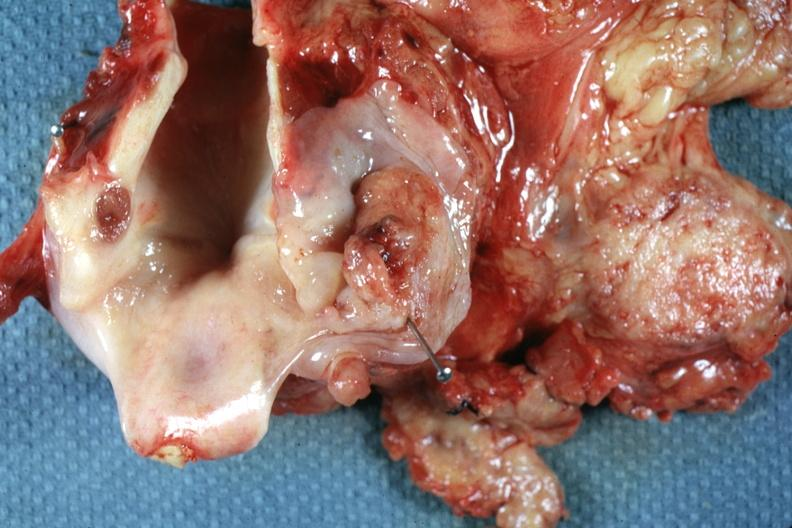what is present?
Answer the question using a single word or phrase. Hypopharynx 